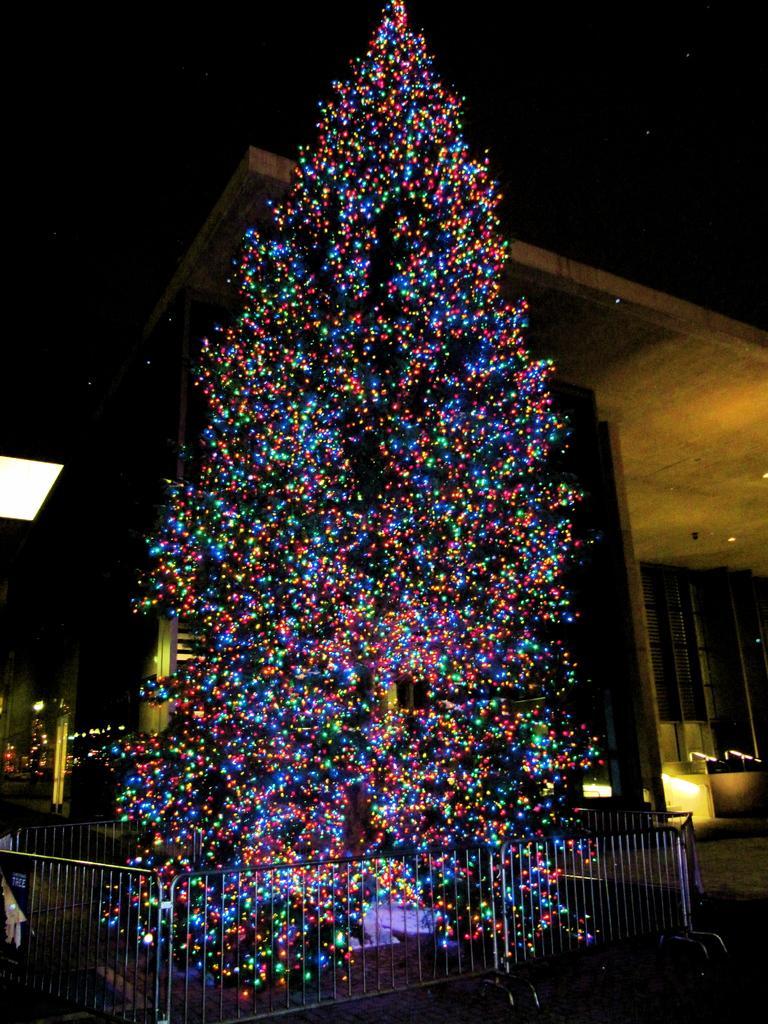Could you give a brief overview of what you see in this image? In this picture we can see a tree with lights on it, in front of the tree we can find fence, in the background we can see a building and few lights. 